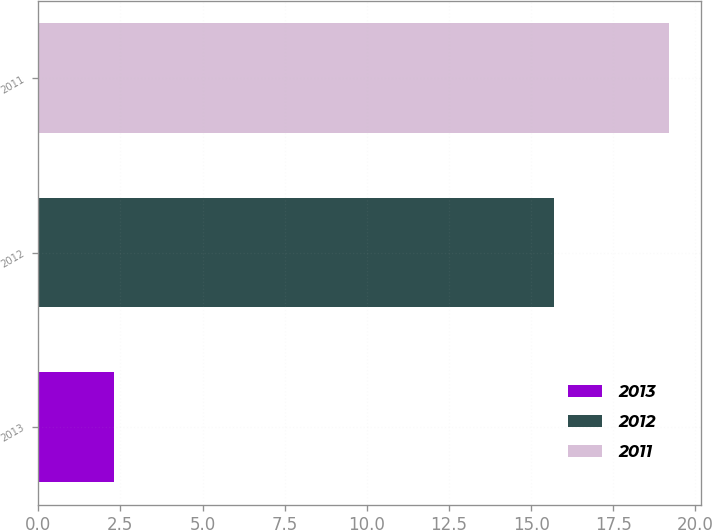Convert chart. <chart><loc_0><loc_0><loc_500><loc_500><bar_chart><fcel>2013<fcel>2012<fcel>2011<nl><fcel>2.3<fcel>15.7<fcel>19.2<nl></chart> 